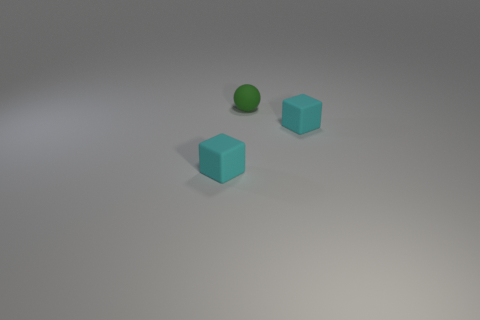Are there any shadows visible, and if so, what could they tell us about the light source? Yes, shadows extend to the right of the objects, indicating that the light source is likely to the left of the scene, possibly above the objects. 